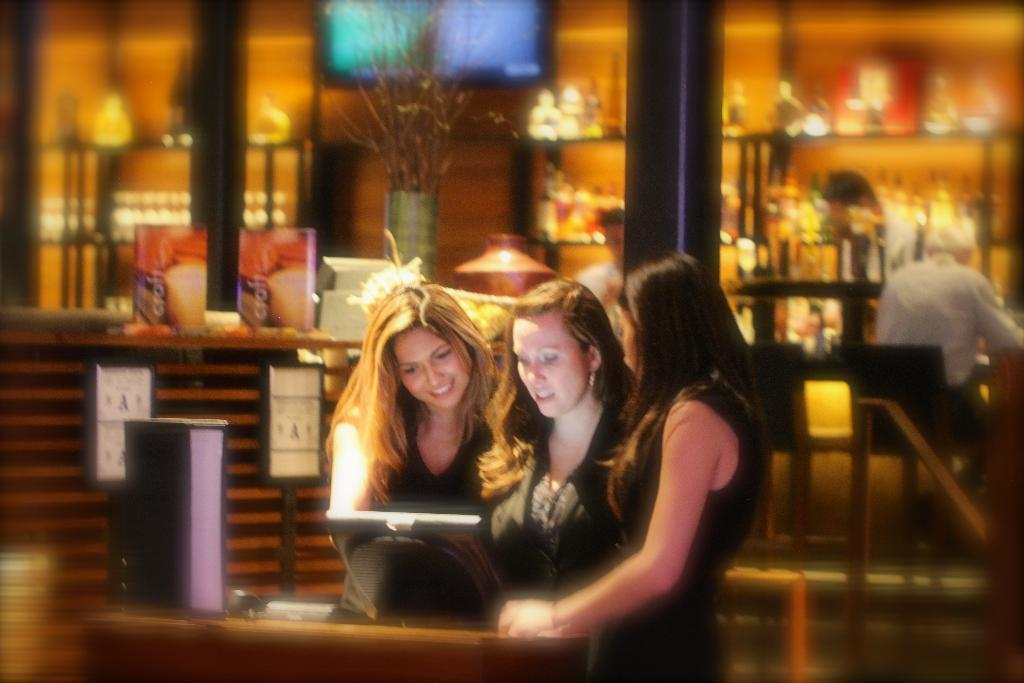How many girls are in the image? There are three girls standing together in the image. What are the girls wearing? The girls are wearing black color dresses. Where is the man in the image located? The man is sitting in a chair on the right side of the image. What type of coast can be seen in the background of the image? There is no coast visible in the image; it features three girls and a man. What kind of patch is being used to fix the man's chair in the image? There is no patch visible in the image, and the man's chair does not appear to be in need of repair. 